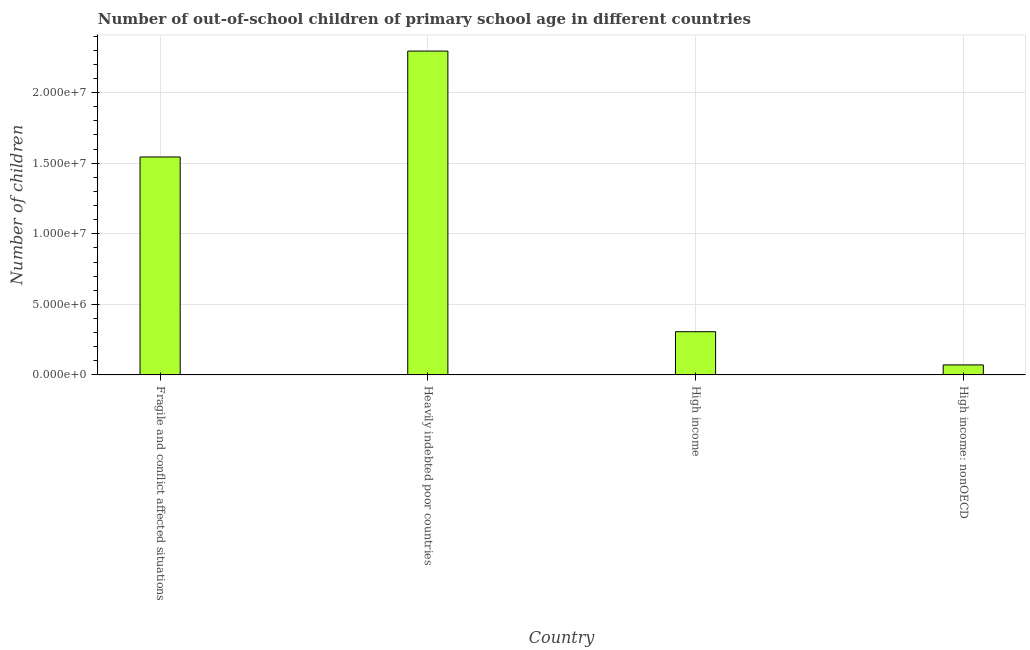What is the title of the graph?
Your response must be concise. Number of out-of-school children of primary school age in different countries. What is the label or title of the X-axis?
Offer a terse response. Country. What is the label or title of the Y-axis?
Provide a short and direct response. Number of children. What is the number of out-of-school children in Fragile and conflict affected situations?
Offer a very short reply. 1.54e+07. Across all countries, what is the maximum number of out-of-school children?
Your response must be concise. 2.29e+07. Across all countries, what is the minimum number of out-of-school children?
Your response must be concise. 7.09e+05. In which country was the number of out-of-school children maximum?
Ensure brevity in your answer.  Heavily indebted poor countries. In which country was the number of out-of-school children minimum?
Provide a short and direct response. High income: nonOECD. What is the sum of the number of out-of-school children?
Your response must be concise. 4.22e+07. What is the difference between the number of out-of-school children in High income and High income: nonOECD?
Provide a succinct answer. 2.35e+06. What is the average number of out-of-school children per country?
Offer a terse response. 1.05e+07. What is the median number of out-of-school children?
Make the answer very short. 9.25e+06. In how many countries, is the number of out-of-school children greater than 1000000 ?
Give a very brief answer. 3. What is the ratio of the number of out-of-school children in Fragile and conflict affected situations to that in Heavily indebted poor countries?
Provide a short and direct response. 0.67. Is the number of out-of-school children in Fragile and conflict affected situations less than that in Heavily indebted poor countries?
Offer a terse response. Yes. What is the difference between the highest and the second highest number of out-of-school children?
Keep it short and to the point. 7.50e+06. What is the difference between the highest and the lowest number of out-of-school children?
Your response must be concise. 2.22e+07. How many countries are there in the graph?
Your answer should be very brief. 4. What is the difference between two consecutive major ticks on the Y-axis?
Your answer should be very brief. 5.00e+06. What is the Number of children of Fragile and conflict affected situations?
Provide a succinct answer. 1.54e+07. What is the Number of children in Heavily indebted poor countries?
Make the answer very short. 2.29e+07. What is the Number of children of High income?
Your answer should be very brief. 3.06e+06. What is the Number of children of High income: nonOECD?
Give a very brief answer. 7.09e+05. What is the difference between the Number of children in Fragile and conflict affected situations and Heavily indebted poor countries?
Ensure brevity in your answer.  -7.50e+06. What is the difference between the Number of children in Fragile and conflict affected situations and High income?
Offer a terse response. 1.24e+07. What is the difference between the Number of children in Fragile and conflict affected situations and High income: nonOECD?
Give a very brief answer. 1.47e+07. What is the difference between the Number of children in Heavily indebted poor countries and High income?
Your response must be concise. 1.99e+07. What is the difference between the Number of children in Heavily indebted poor countries and High income: nonOECD?
Provide a succinct answer. 2.22e+07. What is the difference between the Number of children in High income and High income: nonOECD?
Your answer should be compact. 2.35e+06. What is the ratio of the Number of children in Fragile and conflict affected situations to that in Heavily indebted poor countries?
Provide a succinct answer. 0.67. What is the ratio of the Number of children in Fragile and conflict affected situations to that in High income?
Offer a very short reply. 5.04. What is the ratio of the Number of children in Fragile and conflict affected situations to that in High income: nonOECD?
Give a very brief answer. 21.79. What is the ratio of the Number of children in Heavily indebted poor countries to that in High income?
Provide a short and direct response. 7.5. What is the ratio of the Number of children in Heavily indebted poor countries to that in High income: nonOECD?
Your answer should be very brief. 32.38. What is the ratio of the Number of children in High income to that in High income: nonOECD?
Give a very brief answer. 4.32. 